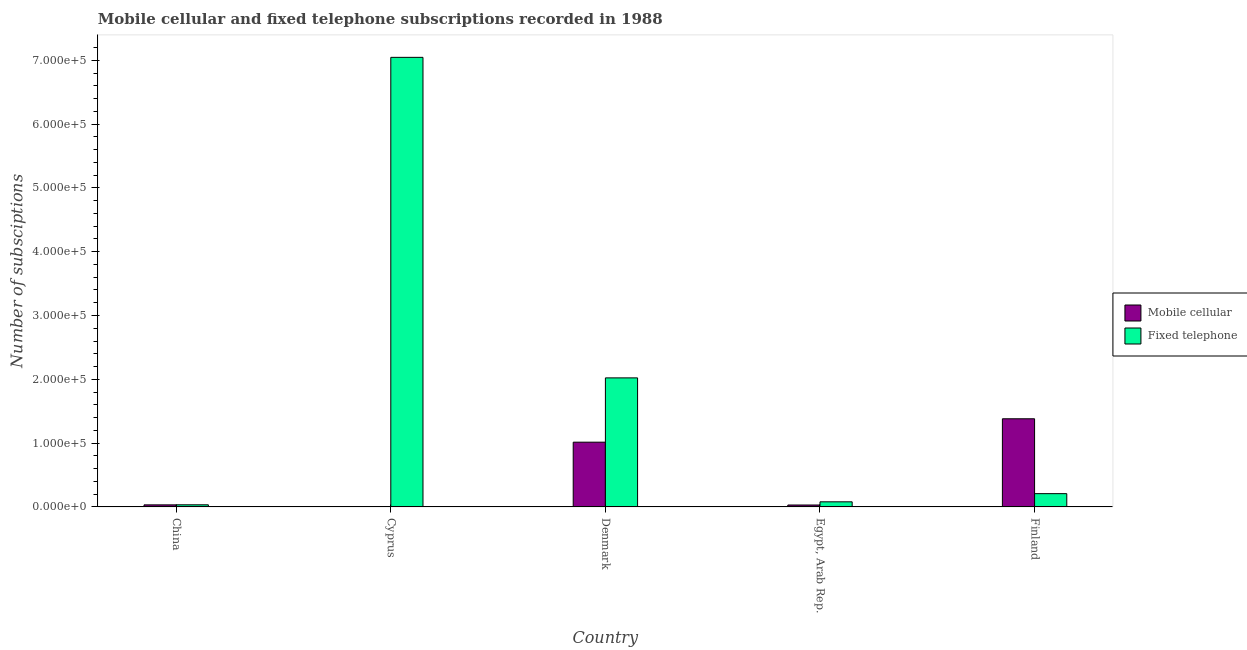How many different coloured bars are there?
Ensure brevity in your answer.  2. How many groups of bars are there?
Ensure brevity in your answer.  5. How many bars are there on the 4th tick from the left?
Your answer should be very brief. 2. How many bars are there on the 3rd tick from the right?
Offer a very short reply. 2. What is the label of the 2nd group of bars from the left?
Your response must be concise. Cyprus. What is the number of fixed telephone subscriptions in Denmark?
Your answer should be very brief. 2.02e+05. Across all countries, what is the maximum number of fixed telephone subscriptions?
Offer a very short reply. 7.05e+05. Across all countries, what is the minimum number of fixed telephone subscriptions?
Keep it short and to the point. 3319. In which country was the number of fixed telephone subscriptions maximum?
Keep it short and to the point. Cyprus. In which country was the number of mobile cellular subscriptions minimum?
Make the answer very short. Cyprus. What is the total number of fixed telephone subscriptions in the graph?
Your answer should be very brief. 9.39e+05. What is the difference between the number of mobile cellular subscriptions in China and that in Denmark?
Offer a very short reply. -9.83e+04. What is the difference between the number of mobile cellular subscriptions in Cyprus and the number of fixed telephone subscriptions in Finland?
Provide a short and direct response. -2.06e+04. What is the average number of fixed telephone subscriptions per country?
Give a very brief answer. 1.88e+05. What is the difference between the number of fixed telephone subscriptions and number of mobile cellular subscriptions in Finland?
Provide a succinct answer. -1.17e+05. What is the ratio of the number of fixed telephone subscriptions in China to that in Cyprus?
Your response must be concise. 0. What is the difference between the highest and the second highest number of mobile cellular subscriptions?
Ensure brevity in your answer.  3.67e+04. What is the difference between the highest and the lowest number of mobile cellular subscriptions?
Your answer should be very brief. 1.38e+05. In how many countries, is the number of mobile cellular subscriptions greater than the average number of mobile cellular subscriptions taken over all countries?
Provide a short and direct response. 2. Is the sum of the number of mobile cellular subscriptions in China and Cyprus greater than the maximum number of fixed telephone subscriptions across all countries?
Give a very brief answer. No. What does the 1st bar from the left in Cyprus represents?
Provide a short and direct response. Mobile cellular. What does the 1st bar from the right in Cyprus represents?
Keep it short and to the point. Fixed telephone. Are all the bars in the graph horizontal?
Offer a very short reply. No. What is the difference between two consecutive major ticks on the Y-axis?
Give a very brief answer. 1.00e+05. Are the values on the major ticks of Y-axis written in scientific E-notation?
Offer a very short reply. Yes. Does the graph contain grids?
Keep it short and to the point. No. How are the legend labels stacked?
Your answer should be compact. Vertical. What is the title of the graph?
Make the answer very short. Mobile cellular and fixed telephone subscriptions recorded in 1988. Does "Drinking water services" appear as one of the legend labels in the graph?
Offer a very short reply. No. What is the label or title of the X-axis?
Provide a succinct answer. Country. What is the label or title of the Y-axis?
Provide a short and direct response. Number of subsciptions. What is the Number of subsciptions in Mobile cellular in China?
Give a very brief answer. 3227. What is the Number of subsciptions of Fixed telephone in China?
Provide a succinct answer. 3319. What is the Number of subsciptions in Mobile cellular in Cyprus?
Offer a terse response. 168. What is the Number of subsciptions of Fixed telephone in Cyprus?
Your response must be concise. 7.05e+05. What is the Number of subsciptions in Mobile cellular in Denmark?
Your answer should be very brief. 1.01e+05. What is the Number of subsciptions in Fixed telephone in Denmark?
Keep it short and to the point. 2.02e+05. What is the Number of subsciptions of Mobile cellular in Egypt, Arab Rep.?
Ensure brevity in your answer.  3021. What is the Number of subsciptions of Fixed telephone in Egypt, Arab Rep.?
Give a very brief answer. 8000. What is the Number of subsciptions of Mobile cellular in Finland?
Ensure brevity in your answer.  1.38e+05. What is the Number of subsciptions in Fixed telephone in Finland?
Provide a short and direct response. 2.08e+04. Across all countries, what is the maximum Number of subsciptions in Mobile cellular?
Provide a succinct answer. 1.38e+05. Across all countries, what is the maximum Number of subsciptions in Fixed telephone?
Your response must be concise. 7.05e+05. Across all countries, what is the minimum Number of subsciptions of Mobile cellular?
Make the answer very short. 168. Across all countries, what is the minimum Number of subsciptions of Fixed telephone?
Your answer should be compact. 3319. What is the total Number of subsciptions in Mobile cellular in the graph?
Provide a succinct answer. 2.46e+05. What is the total Number of subsciptions in Fixed telephone in the graph?
Ensure brevity in your answer.  9.39e+05. What is the difference between the Number of subsciptions of Mobile cellular in China and that in Cyprus?
Make the answer very short. 3059. What is the difference between the Number of subsciptions in Fixed telephone in China and that in Cyprus?
Offer a very short reply. -7.01e+05. What is the difference between the Number of subsciptions of Mobile cellular in China and that in Denmark?
Your answer should be compact. -9.83e+04. What is the difference between the Number of subsciptions of Fixed telephone in China and that in Denmark?
Keep it short and to the point. -1.99e+05. What is the difference between the Number of subsciptions in Mobile cellular in China and that in Egypt, Arab Rep.?
Provide a short and direct response. 206. What is the difference between the Number of subsciptions in Fixed telephone in China and that in Egypt, Arab Rep.?
Provide a short and direct response. -4681. What is the difference between the Number of subsciptions of Mobile cellular in China and that in Finland?
Your answer should be very brief. -1.35e+05. What is the difference between the Number of subsciptions of Fixed telephone in China and that in Finland?
Offer a very short reply. -1.75e+04. What is the difference between the Number of subsciptions in Mobile cellular in Cyprus and that in Denmark?
Offer a very short reply. -1.01e+05. What is the difference between the Number of subsciptions of Fixed telephone in Cyprus and that in Denmark?
Keep it short and to the point. 5.02e+05. What is the difference between the Number of subsciptions of Mobile cellular in Cyprus and that in Egypt, Arab Rep.?
Keep it short and to the point. -2853. What is the difference between the Number of subsciptions in Fixed telephone in Cyprus and that in Egypt, Arab Rep.?
Keep it short and to the point. 6.97e+05. What is the difference between the Number of subsciptions in Mobile cellular in Cyprus and that in Finland?
Give a very brief answer. -1.38e+05. What is the difference between the Number of subsciptions in Fixed telephone in Cyprus and that in Finland?
Your response must be concise. 6.84e+05. What is the difference between the Number of subsciptions in Mobile cellular in Denmark and that in Egypt, Arab Rep.?
Offer a terse response. 9.85e+04. What is the difference between the Number of subsciptions in Fixed telephone in Denmark and that in Egypt, Arab Rep.?
Your response must be concise. 1.94e+05. What is the difference between the Number of subsciptions of Mobile cellular in Denmark and that in Finland?
Give a very brief answer. -3.67e+04. What is the difference between the Number of subsciptions in Fixed telephone in Denmark and that in Finland?
Offer a very short reply. 1.81e+05. What is the difference between the Number of subsciptions in Mobile cellular in Egypt, Arab Rep. and that in Finland?
Offer a terse response. -1.35e+05. What is the difference between the Number of subsciptions in Fixed telephone in Egypt, Arab Rep. and that in Finland?
Offer a very short reply. -1.28e+04. What is the difference between the Number of subsciptions of Mobile cellular in China and the Number of subsciptions of Fixed telephone in Cyprus?
Provide a succinct answer. -7.01e+05. What is the difference between the Number of subsciptions in Mobile cellular in China and the Number of subsciptions in Fixed telephone in Denmark?
Ensure brevity in your answer.  -1.99e+05. What is the difference between the Number of subsciptions of Mobile cellular in China and the Number of subsciptions of Fixed telephone in Egypt, Arab Rep.?
Keep it short and to the point. -4773. What is the difference between the Number of subsciptions of Mobile cellular in China and the Number of subsciptions of Fixed telephone in Finland?
Offer a terse response. -1.76e+04. What is the difference between the Number of subsciptions of Mobile cellular in Cyprus and the Number of subsciptions of Fixed telephone in Denmark?
Give a very brief answer. -2.02e+05. What is the difference between the Number of subsciptions in Mobile cellular in Cyprus and the Number of subsciptions in Fixed telephone in Egypt, Arab Rep.?
Give a very brief answer. -7832. What is the difference between the Number of subsciptions in Mobile cellular in Cyprus and the Number of subsciptions in Fixed telephone in Finland?
Your response must be concise. -2.06e+04. What is the difference between the Number of subsciptions in Mobile cellular in Denmark and the Number of subsciptions in Fixed telephone in Egypt, Arab Rep.?
Offer a very short reply. 9.35e+04. What is the difference between the Number of subsciptions of Mobile cellular in Denmark and the Number of subsciptions of Fixed telephone in Finland?
Ensure brevity in your answer.  8.07e+04. What is the difference between the Number of subsciptions of Mobile cellular in Egypt, Arab Rep. and the Number of subsciptions of Fixed telephone in Finland?
Offer a very short reply. -1.78e+04. What is the average Number of subsciptions of Mobile cellular per country?
Give a very brief answer. 4.92e+04. What is the average Number of subsciptions of Fixed telephone per country?
Provide a short and direct response. 1.88e+05. What is the difference between the Number of subsciptions of Mobile cellular and Number of subsciptions of Fixed telephone in China?
Your answer should be very brief. -92. What is the difference between the Number of subsciptions in Mobile cellular and Number of subsciptions in Fixed telephone in Cyprus?
Give a very brief answer. -7.04e+05. What is the difference between the Number of subsciptions of Mobile cellular and Number of subsciptions of Fixed telephone in Denmark?
Your response must be concise. -1.01e+05. What is the difference between the Number of subsciptions in Mobile cellular and Number of subsciptions in Fixed telephone in Egypt, Arab Rep.?
Offer a terse response. -4979. What is the difference between the Number of subsciptions of Mobile cellular and Number of subsciptions of Fixed telephone in Finland?
Your response must be concise. 1.17e+05. What is the ratio of the Number of subsciptions in Mobile cellular in China to that in Cyprus?
Provide a succinct answer. 19.21. What is the ratio of the Number of subsciptions of Fixed telephone in China to that in Cyprus?
Give a very brief answer. 0. What is the ratio of the Number of subsciptions of Mobile cellular in China to that in Denmark?
Keep it short and to the point. 0.03. What is the ratio of the Number of subsciptions in Fixed telephone in China to that in Denmark?
Provide a succinct answer. 0.02. What is the ratio of the Number of subsciptions of Mobile cellular in China to that in Egypt, Arab Rep.?
Keep it short and to the point. 1.07. What is the ratio of the Number of subsciptions in Fixed telephone in China to that in Egypt, Arab Rep.?
Ensure brevity in your answer.  0.41. What is the ratio of the Number of subsciptions in Mobile cellular in China to that in Finland?
Give a very brief answer. 0.02. What is the ratio of the Number of subsciptions in Fixed telephone in China to that in Finland?
Give a very brief answer. 0.16. What is the ratio of the Number of subsciptions in Mobile cellular in Cyprus to that in Denmark?
Provide a succinct answer. 0. What is the ratio of the Number of subsciptions in Fixed telephone in Cyprus to that in Denmark?
Your response must be concise. 3.48. What is the ratio of the Number of subsciptions in Mobile cellular in Cyprus to that in Egypt, Arab Rep.?
Provide a short and direct response. 0.06. What is the ratio of the Number of subsciptions of Fixed telephone in Cyprus to that in Egypt, Arab Rep.?
Your answer should be compact. 88.08. What is the ratio of the Number of subsciptions of Mobile cellular in Cyprus to that in Finland?
Your answer should be very brief. 0. What is the ratio of the Number of subsciptions of Fixed telephone in Cyprus to that in Finland?
Offer a very short reply. 33.85. What is the ratio of the Number of subsciptions in Mobile cellular in Denmark to that in Egypt, Arab Rep.?
Keep it short and to the point. 33.59. What is the ratio of the Number of subsciptions of Fixed telephone in Denmark to that in Egypt, Arab Rep.?
Give a very brief answer. 25.28. What is the ratio of the Number of subsciptions in Mobile cellular in Denmark to that in Finland?
Provide a succinct answer. 0.73. What is the ratio of the Number of subsciptions in Fixed telephone in Denmark to that in Finland?
Your answer should be very brief. 9.72. What is the ratio of the Number of subsciptions of Mobile cellular in Egypt, Arab Rep. to that in Finland?
Provide a short and direct response. 0.02. What is the ratio of the Number of subsciptions in Fixed telephone in Egypt, Arab Rep. to that in Finland?
Your answer should be very brief. 0.38. What is the difference between the highest and the second highest Number of subsciptions in Mobile cellular?
Ensure brevity in your answer.  3.67e+04. What is the difference between the highest and the second highest Number of subsciptions in Fixed telephone?
Ensure brevity in your answer.  5.02e+05. What is the difference between the highest and the lowest Number of subsciptions of Mobile cellular?
Make the answer very short. 1.38e+05. What is the difference between the highest and the lowest Number of subsciptions in Fixed telephone?
Ensure brevity in your answer.  7.01e+05. 